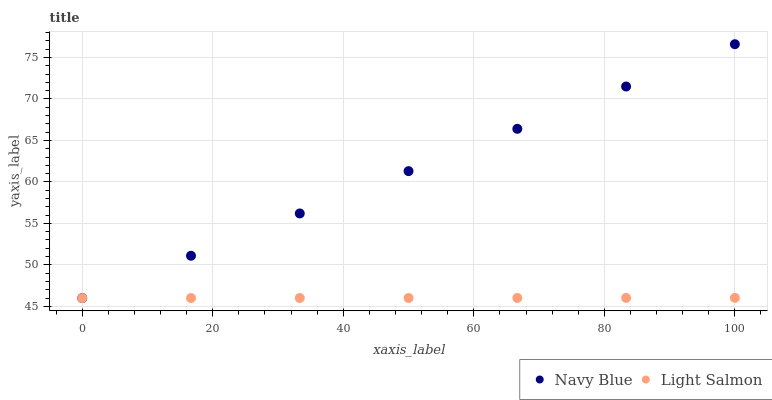Does Light Salmon have the minimum area under the curve?
Answer yes or no. Yes. Does Navy Blue have the maximum area under the curve?
Answer yes or no. Yes. Does Light Salmon have the maximum area under the curve?
Answer yes or no. No. Is Light Salmon the smoothest?
Answer yes or no. Yes. Is Navy Blue the roughest?
Answer yes or no. Yes. Is Light Salmon the roughest?
Answer yes or no. No. Does Navy Blue have the lowest value?
Answer yes or no. Yes. Does Navy Blue have the highest value?
Answer yes or no. Yes. Does Light Salmon have the highest value?
Answer yes or no. No. Does Light Salmon intersect Navy Blue?
Answer yes or no. Yes. Is Light Salmon less than Navy Blue?
Answer yes or no. No. Is Light Salmon greater than Navy Blue?
Answer yes or no. No. 